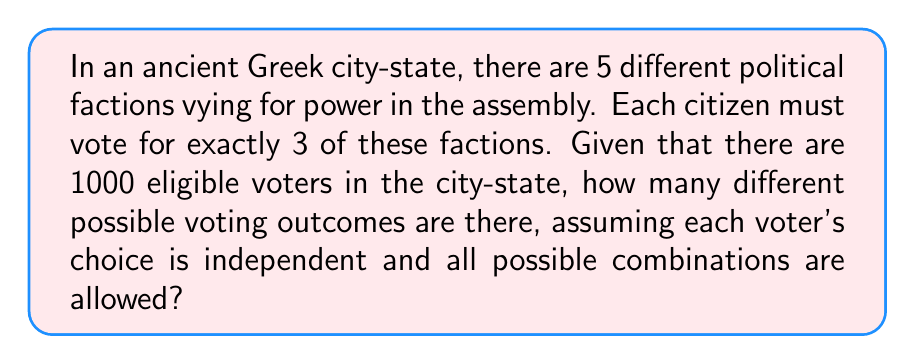Help me with this question. To solve this problem, we need to follow these steps:

1) First, we need to determine how many ways each individual voter can cast their vote. This is a combination problem, as the order of selection doesn't matter.

2) We are choosing 3 factions out of 5, which can be represented as $\binom{5}{3}$.

3) The formula for this combination is:

   $$\binom{5}{3} = \frac{5!}{3!(5-3)!} = \frac{5!}{3!2!}$$

4) Calculating this:
   $$\frac{5 \cdot 4 \cdot 3!}{3! \cdot 2 \cdot 1} = \frac{20}{2} = 10$$

5) So each voter has 10 possible ways to vote.

6) Now, we need to consider all 1000 voters. Each voter's choice is independent, so we use the multiplication principle.

7) The total number of possible voting outcomes is thus:

   $$10^{1000}$$

This is an extremely large number, reflecting the complexity of voting systems even in ancient times.
Answer: $10^{1000}$ 